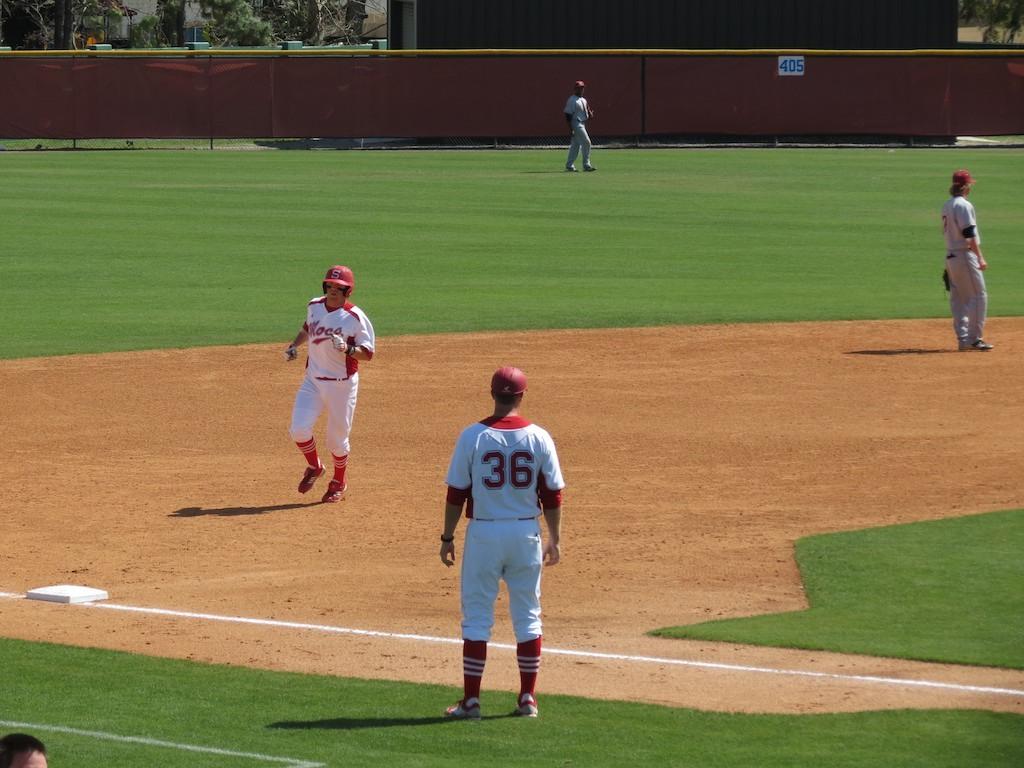What number is that player?
Provide a short and direct response. 36. 